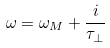Convert formula to latex. <formula><loc_0><loc_0><loc_500><loc_500>\omega = \omega _ { M } + \frac { i } { \tau _ { \bot } }</formula> 